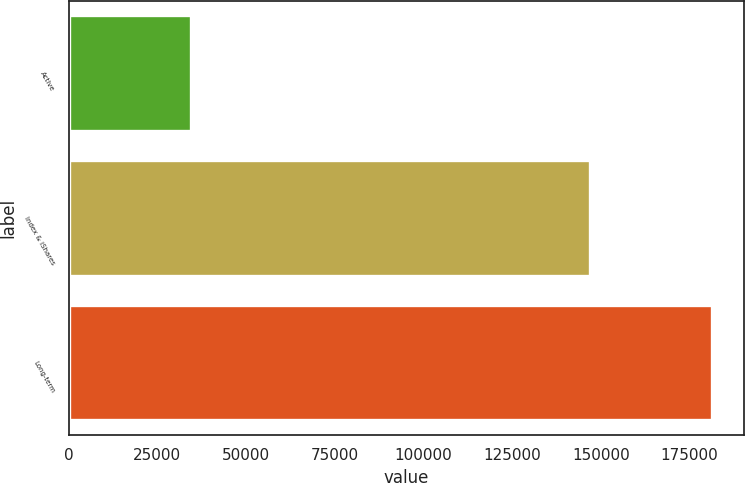Convert chart to OTSL. <chart><loc_0><loc_0><loc_500><loc_500><bar_chart><fcel>Active<fcel>Index & iShares<fcel>Long-term<nl><fcel>34408<fcel>146845<fcel>181253<nl></chart> 